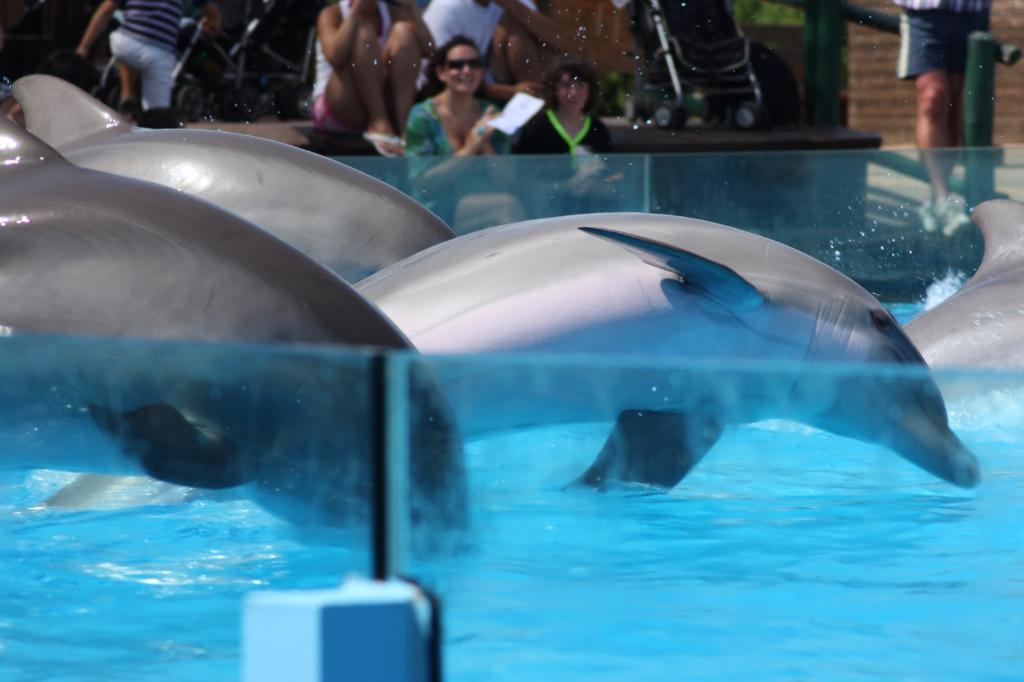What animals can be seen in the water in the image? There are dolphins in the water in the image. What type of barrier is present in the image? There are glass fences in the image. What can be seen in the background of the image? In the background, there are people sitting, a paper, a stroller, and other unspecified objects. What type of trade is being conducted in the image? There is no indication of any trade being conducted in the image; it primarily features dolphins in the water and glass fences. How many eggs are visible in the image? There are no eggs present in the image. 